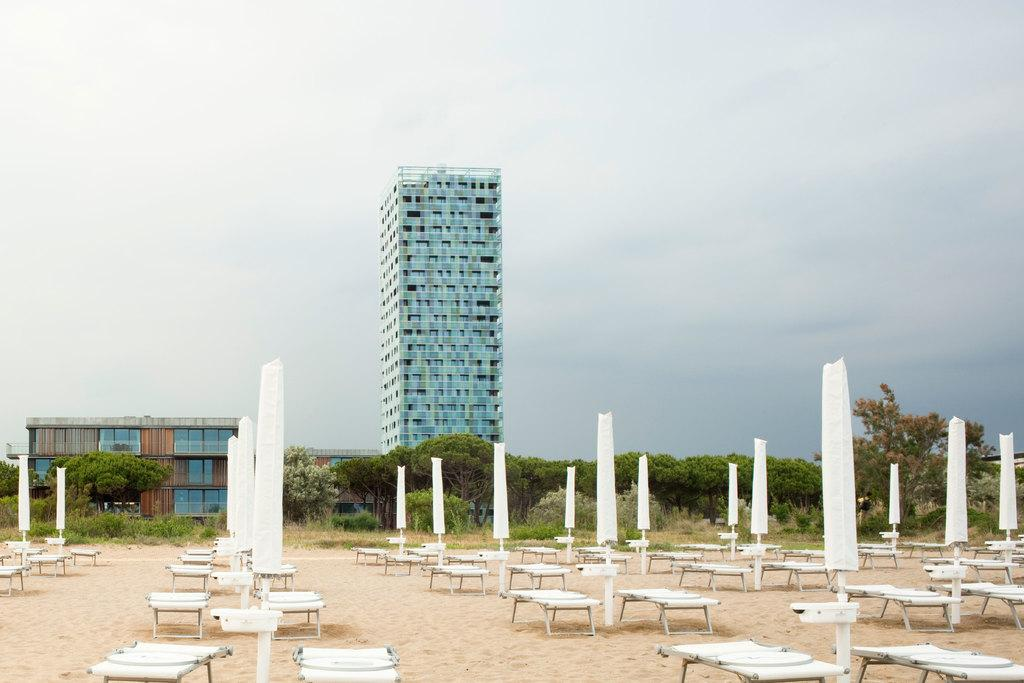What objects are located in the foreground of the image? There are tables and poles in the foreground of the image. What can be seen in the middle of the image? There is a building and trees in the middle of the image. What is visible at the top of the image? The sky is visible at the top of the image. How many beggars are sitting on the chairs in the image? There are no beggars or chairs present in the image. What type of road can be seen in the image? There is no road visible in the image; it features tables, poles, a building, trees, and the sky. 